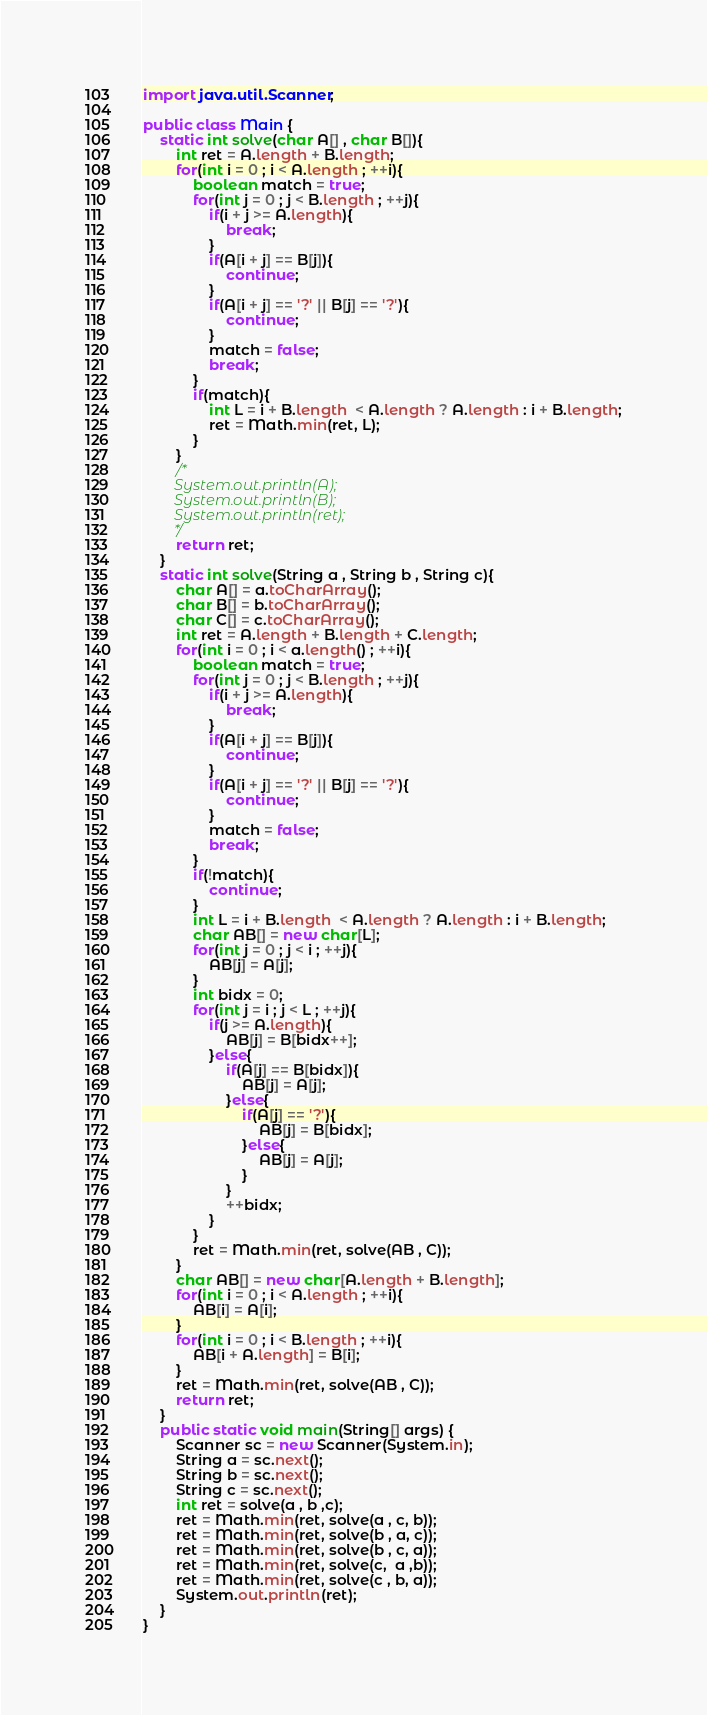Convert code to text. <code><loc_0><loc_0><loc_500><loc_500><_Java_>import java.util.Scanner;

public class Main {
	static int solve(char A[] , char B[]){
		int ret = A.length + B.length;
		for(int i = 0 ; i < A.length ; ++i){
			boolean match = true;
			for(int j = 0 ; j < B.length ; ++j){
				if(i + j >= A.length){
					break;
				}
				if(A[i + j] == B[j]){
					continue;
				}
				if(A[i + j] == '?' || B[j] == '?'){
					continue;
				}
				match = false;
				break;
			}
			if(match){
				int L = i + B.length  < A.length ? A.length : i + B.length;
				ret = Math.min(ret, L);
			}
		}
		/*
		System.out.println(A);
		System.out.println(B);
		System.out.println(ret);
		*/
		return ret;
	}
	static int solve(String a , String b , String c){
		char A[] = a.toCharArray();
		char B[] = b.toCharArray();
		char C[] = c.toCharArray();
		int ret = A.length + B.length + C.length;
		for(int i = 0 ; i < a.length() ; ++i){
			boolean match = true;
			for(int j = 0 ; j < B.length ; ++j){
				if(i + j >= A.length){
					break;
				}
				if(A[i + j] == B[j]){
					continue;
				}
				if(A[i + j] == '?' || B[j] == '?'){
					continue;
				}
				match = false;
				break;
			}
			if(!match){
				continue;
			}
			int L = i + B.length  < A.length ? A.length : i + B.length;
			char AB[] = new char[L];
			for(int j = 0 ; j < i ; ++j){
				AB[j] = A[j];
			}
			int bidx = 0;
			for(int j = i ; j < L ; ++j){
				if(j >= A.length){
					AB[j] = B[bidx++];
				}else{
					if(A[j] == B[bidx]){
						AB[j] = A[j];
					}else{
						if(A[j] == '?'){
							AB[j] = B[bidx];
						}else{
							AB[j] = A[j];
						}
					}
					++bidx;
				}
			}
			ret = Math.min(ret, solve(AB , C));
		}
		char AB[] = new char[A.length + B.length];
		for(int i = 0 ; i < A.length ; ++i){
			AB[i] = A[i];
		}
		for(int i = 0 ; i < B.length ; ++i){
			AB[i + A.length] = B[i];
		}
		ret = Math.min(ret, solve(AB , C));
		return ret;
	}
	public static void main(String[] args) {
		Scanner sc = new Scanner(System.in);
		String a = sc.next();
		String b = sc.next();
		String c = sc.next();
		int ret = solve(a , b ,c);
		ret = Math.min(ret, solve(a , c, b));
		ret = Math.min(ret, solve(b , a, c));
		ret = Math.min(ret, solve(b , c, a));
		ret = Math.min(ret, solve(c,  a ,b));
		ret = Math.min(ret, solve(c , b, a));
		System.out.println(ret);
	}
}
</code> 